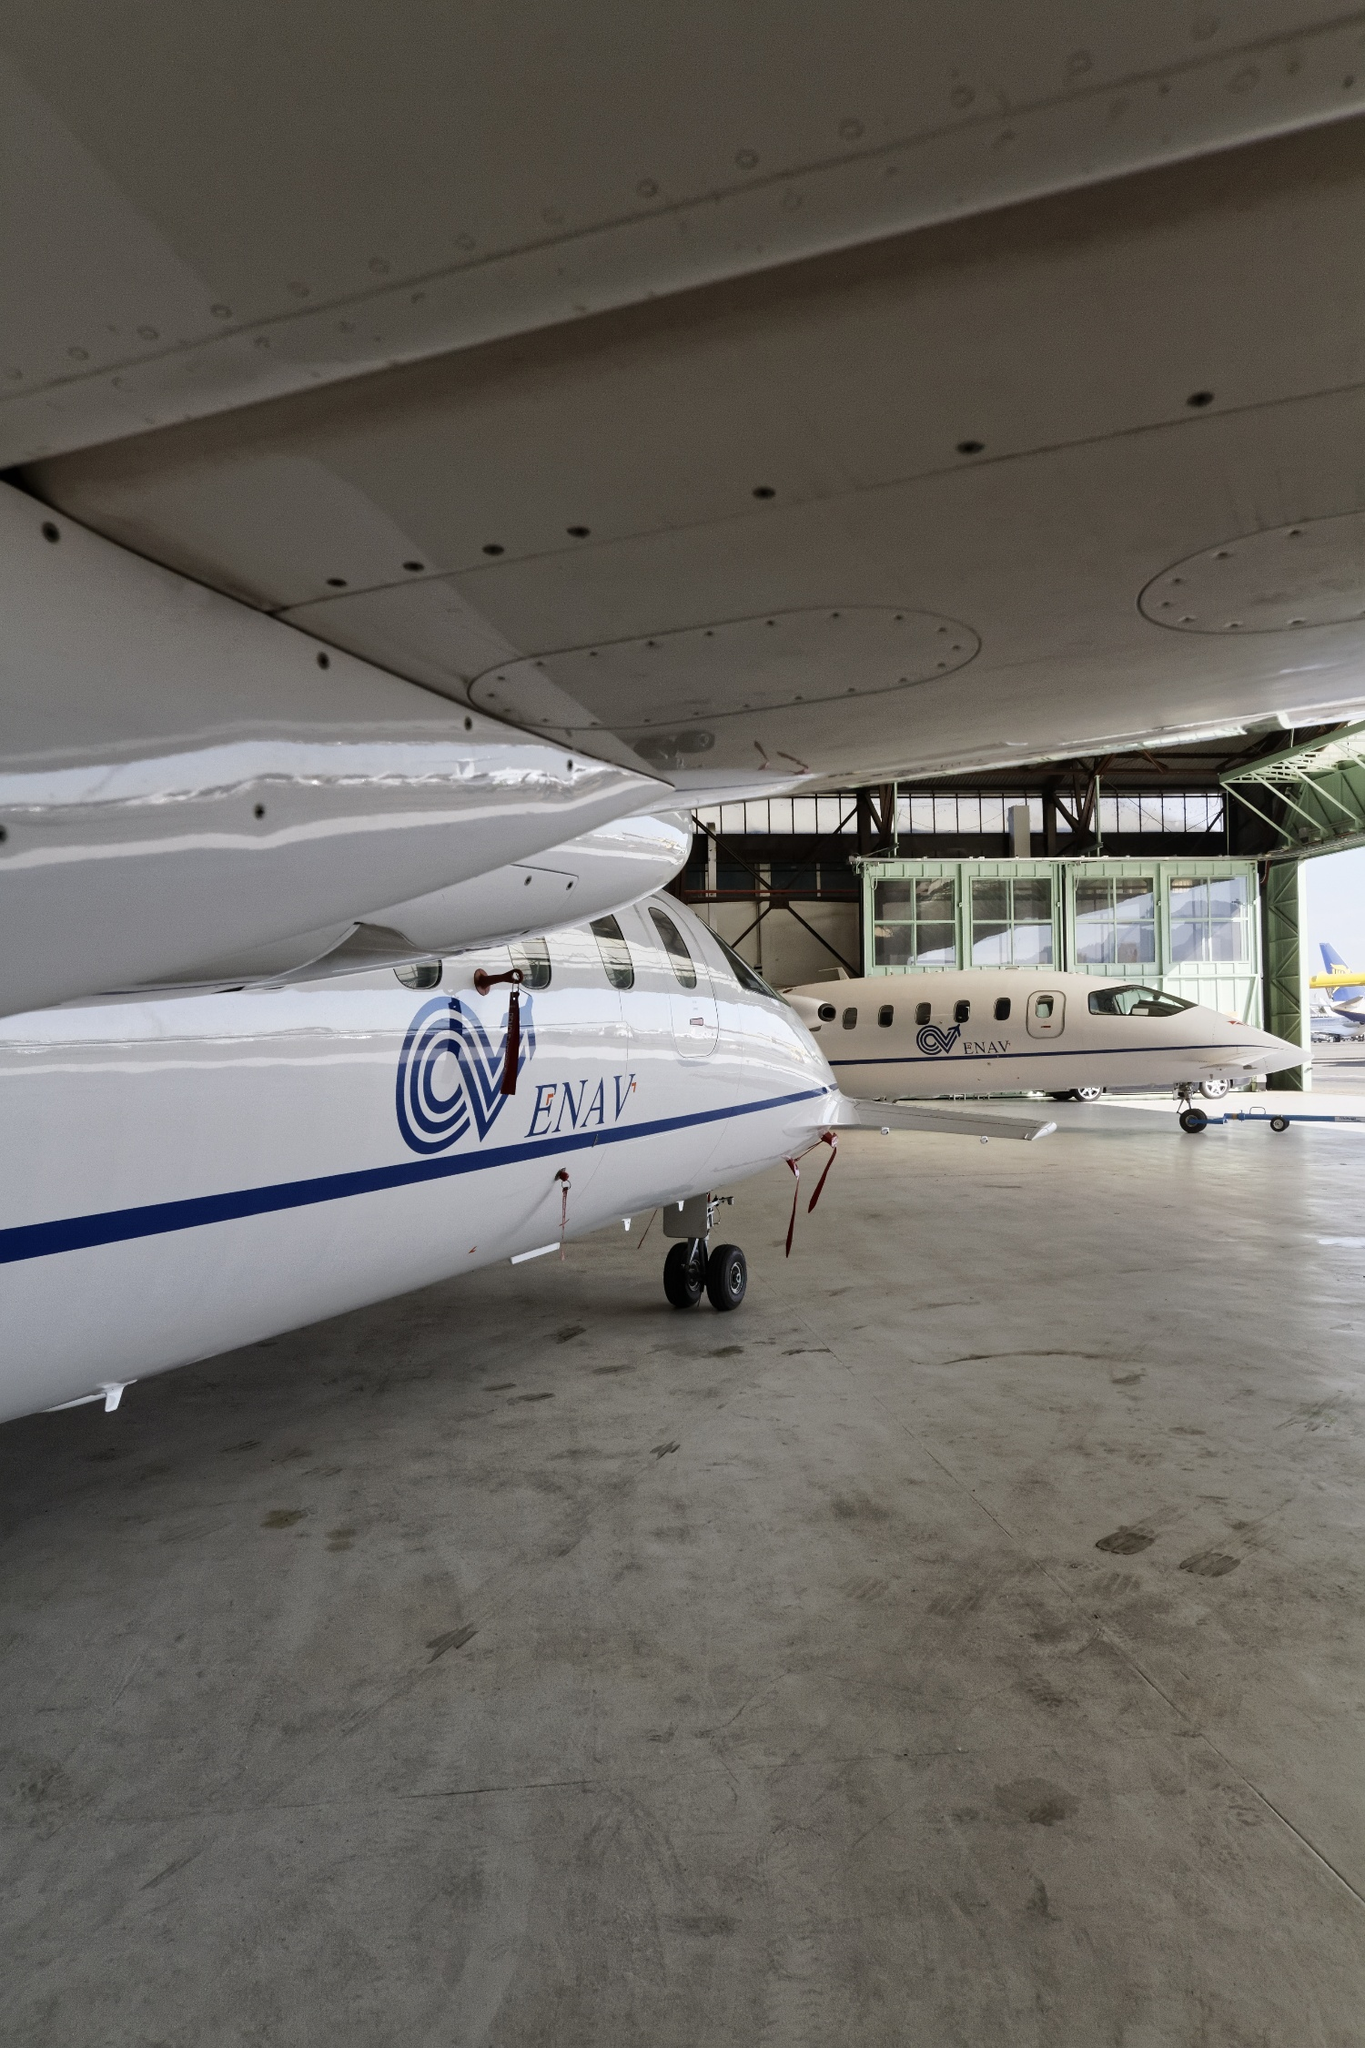What's happening in the scene? The image depicts the interior of an airplane hangar housing two aircraft. The first aircraft, closest to the viewer, features a white and blue color scheme with a distinctive red stripe and the ENAV logo prominently displayed. The second aircraft in the background is also predominantly white with gray accents and a blue stripe. The hangar itself is a large concrete structure with a high ceiling equipped with windows, allowing natural light to illuminate the space. This perspective from the ground level emphasizes the size and grandeur of the airplanes. Additionally, the hangar door is partially open, suggesting that these planes might be prepared for upcoming flights or maintenance activity. 